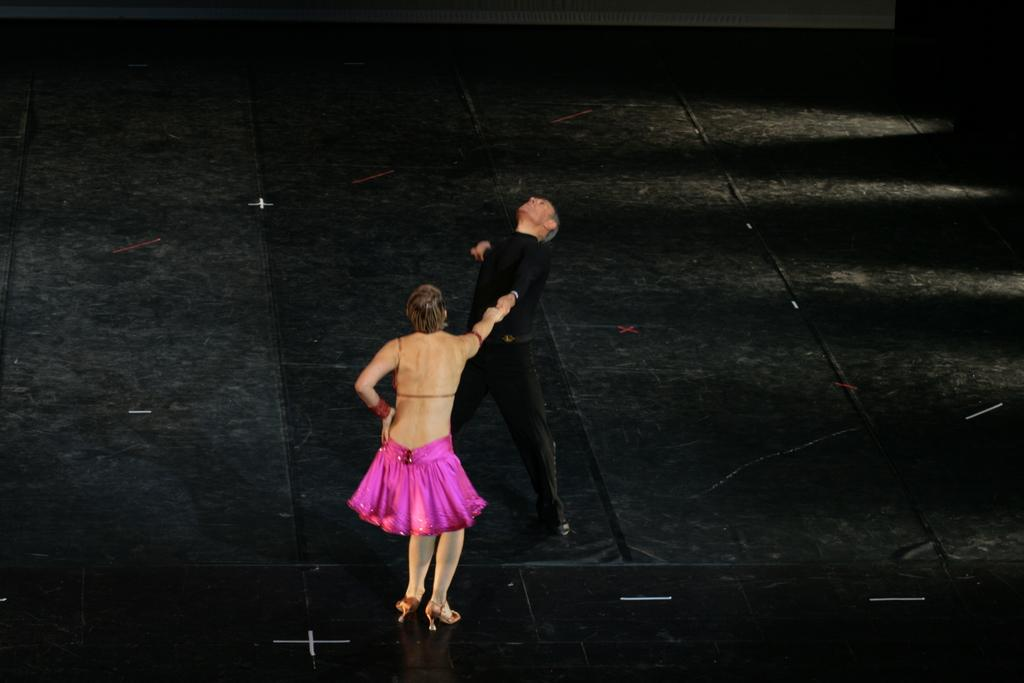How many people are in the image? There are two persons in the image. What are the two persons doing together? The two persons are holding hands and dancing. What surface are they dancing on? There is a floor visible in the image, which they are dancing on. What type of chalk is being used to draw on the grass in the image? There is no chalk or grass present in the image; it features two persons holding hands and dancing on a floor. 